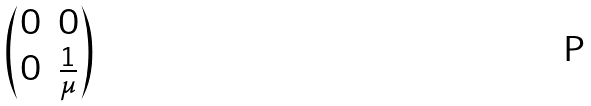<formula> <loc_0><loc_0><loc_500><loc_500>\begin{pmatrix} 0 & 0 \\ 0 & \frac { 1 } { \mu } \end{pmatrix}</formula> 